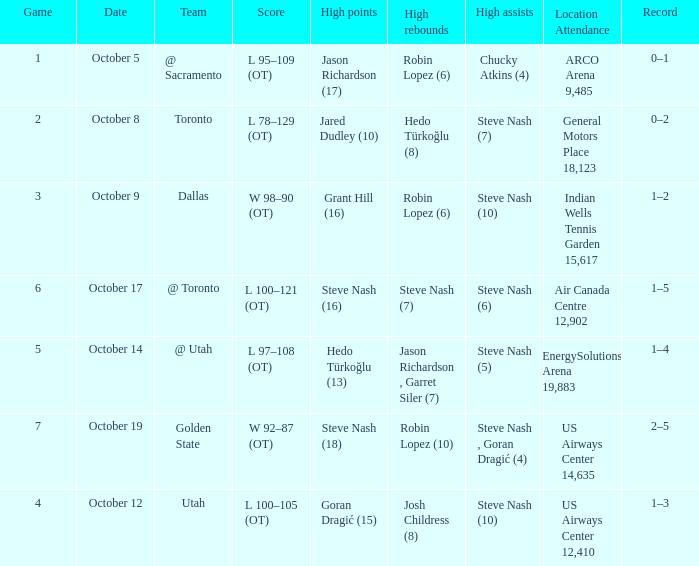What two players had the highest rebounds for the October 14 game? Jason Richardson , Garret Siler (7). 